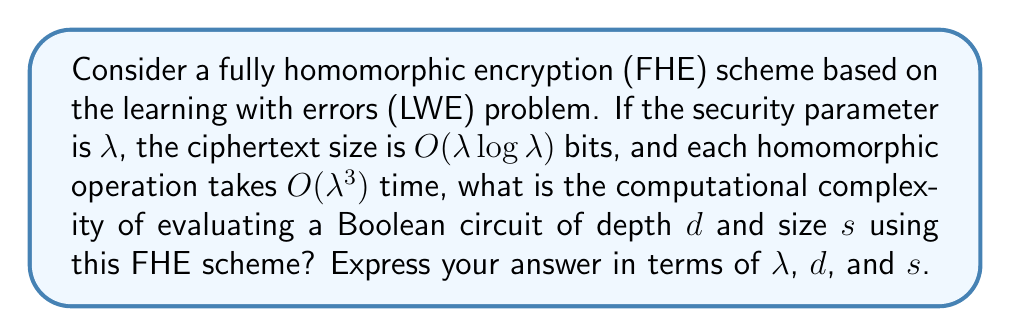Give your solution to this math problem. To determine the computational complexity, we'll follow these steps:

1) In FHE schemes, the noise in ciphertexts grows with each operation. To manage this, we need to perform a "bootstrapping" operation after a certain number of levels in the circuit.

2) The number of bootstrapping operations required is proportional to the depth of the circuit $d$.

3) Each bootstrapping operation typically has a complexity of $O(\lambda^4)$ in LWE-based schemes.

4) For each gate in the circuit, we need to perform a homomorphic operation, which takes $O(\lambda^3)$ time.

5) The total number of gates in the circuit is given by its size $s$.

6) Therefore, the total complexity is:
   
   $$O(d \cdot \lambda^4 + s \cdot \lambda^3)$$

   This accounts for both the bootstrapping operations (first term) and the homomorphic operations for each gate (second term).

7) To express this in a single Big O notation, we take the maximum of these terms:

   $$O(\max(d \cdot \lambda^4, s \cdot \lambda^3))$$

8) We can simplify this further by noting that $d \leq s$ (the depth is always less than or equal to the size of the circuit), so:

   $$O(s \cdot \lambda^4)$$

This represents the worst-case complexity, assuming we need to bootstrap after every level of the circuit.
Answer: $O(s \cdot \lambda^4)$ 